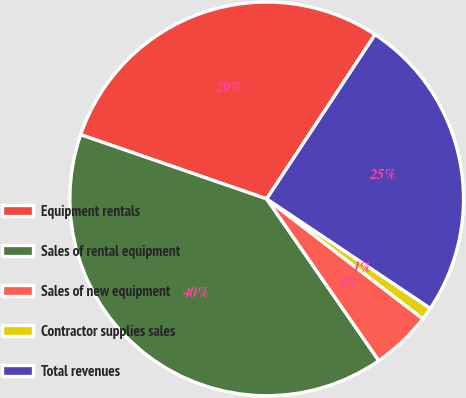Convert chart to OTSL. <chart><loc_0><loc_0><loc_500><loc_500><pie_chart><fcel>Equipment rentals<fcel>Sales of rental equipment<fcel>Sales of new equipment<fcel>Contractor supplies sales<fcel>Total revenues<nl><fcel>28.99%<fcel>39.93%<fcel>4.93%<fcel>1.04%<fcel>25.1%<nl></chart> 